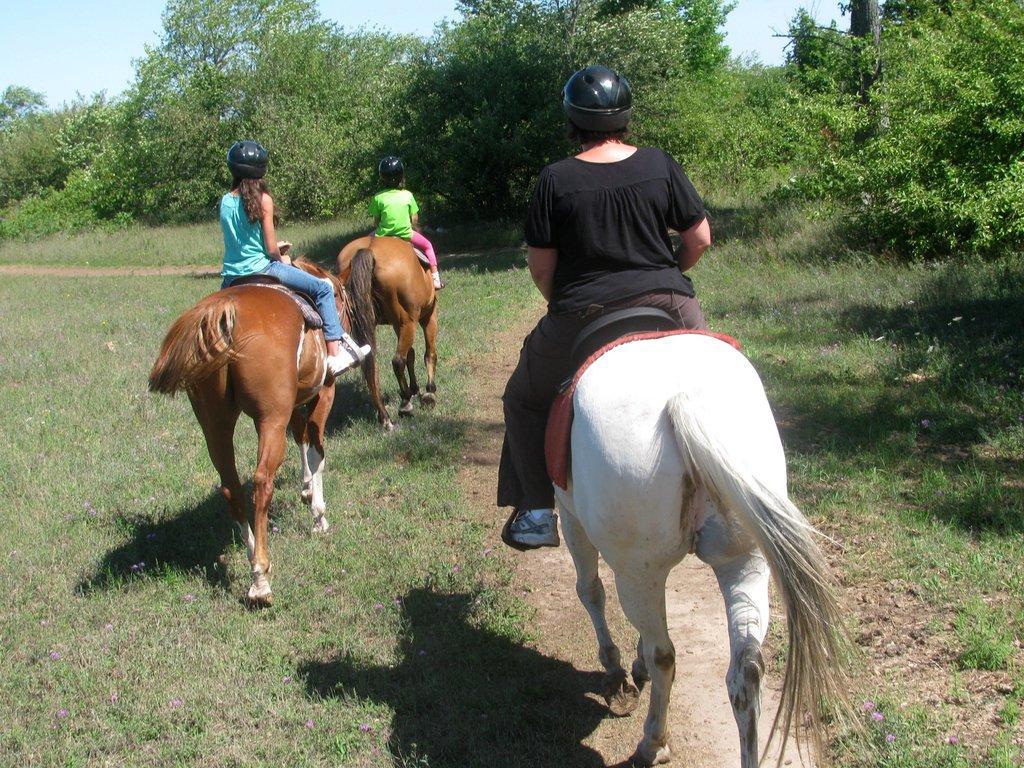Could you give a brief overview of what you see in this image? In front of the picture, we see a woman is riding a white horse. At the bottom, we see the pathway and the grass. On the left side, we see the two girls are riding the brown horses. On the right side, we see the trees. There are trees in the background. At the top, we see the sky. 